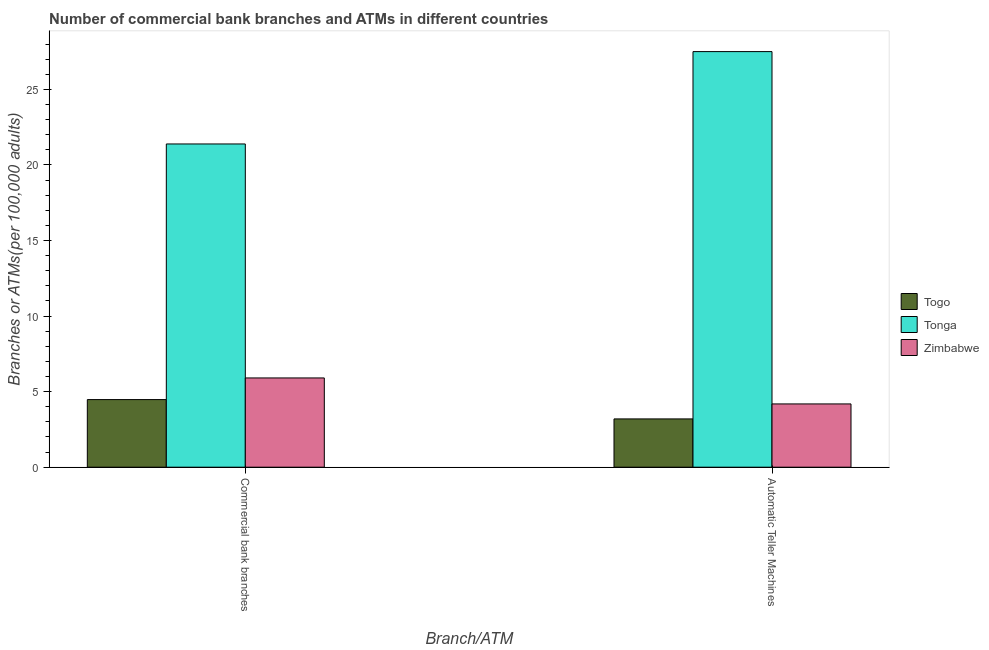What is the label of the 1st group of bars from the left?
Offer a very short reply. Commercial bank branches. What is the number of commercal bank branches in Tonga?
Your response must be concise. 21.39. Across all countries, what is the maximum number of atms?
Ensure brevity in your answer.  27.5. Across all countries, what is the minimum number of atms?
Keep it short and to the point. 3.2. In which country was the number of commercal bank branches maximum?
Offer a terse response. Tonga. In which country was the number of commercal bank branches minimum?
Your response must be concise. Togo. What is the total number of commercal bank branches in the graph?
Provide a short and direct response. 31.77. What is the difference between the number of commercal bank branches in Togo and that in Zimbabwe?
Your answer should be very brief. -1.43. What is the difference between the number of atms in Togo and the number of commercal bank branches in Tonga?
Offer a terse response. -18.19. What is the average number of commercal bank branches per country?
Ensure brevity in your answer.  10.59. What is the difference between the number of commercal bank branches and number of atms in Tonga?
Your answer should be very brief. -6.11. In how many countries, is the number of atms greater than 25 ?
Offer a very short reply. 1. What is the ratio of the number of commercal bank branches in Zimbabwe to that in Tonga?
Ensure brevity in your answer.  0.28. In how many countries, is the number of commercal bank branches greater than the average number of commercal bank branches taken over all countries?
Make the answer very short. 1. What does the 2nd bar from the left in Commercial bank branches represents?
Your answer should be compact. Tonga. What does the 3rd bar from the right in Automatic Teller Machines represents?
Offer a terse response. Togo. How many countries are there in the graph?
Offer a very short reply. 3. What is the difference between two consecutive major ticks on the Y-axis?
Keep it short and to the point. 5. Are the values on the major ticks of Y-axis written in scientific E-notation?
Keep it short and to the point. No. Does the graph contain any zero values?
Give a very brief answer. No. Where does the legend appear in the graph?
Provide a short and direct response. Center right. What is the title of the graph?
Your response must be concise. Number of commercial bank branches and ATMs in different countries. What is the label or title of the X-axis?
Ensure brevity in your answer.  Branch/ATM. What is the label or title of the Y-axis?
Keep it short and to the point. Branches or ATMs(per 100,0 adults). What is the Branches or ATMs(per 100,000 adults) of Togo in Commercial bank branches?
Make the answer very short. 4.47. What is the Branches or ATMs(per 100,000 adults) of Tonga in Commercial bank branches?
Provide a short and direct response. 21.39. What is the Branches or ATMs(per 100,000 adults) of Zimbabwe in Commercial bank branches?
Provide a succinct answer. 5.91. What is the Branches or ATMs(per 100,000 adults) in Togo in Automatic Teller Machines?
Offer a very short reply. 3.2. What is the Branches or ATMs(per 100,000 adults) in Tonga in Automatic Teller Machines?
Your answer should be very brief. 27.5. What is the Branches or ATMs(per 100,000 adults) of Zimbabwe in Automatic Teller Machines?
Give a very brief answer. 4.19. Across all Branch/ATM, what is the maximum Branches or ATMs(per 100,000 adults) in Togo?
Ensure brevity in your answer.  4.47. Across all Branch/ATM, what is the maximum Branches or ATMs(per 100,000 adults) of Tonga?
Offer a very short reply. 27.5. Across all Branch/ATM, what is the maximum Branches or ATMs(per 100,000 adults) of Zimbabwe?
Provide a short and direct response. 5.91. Across all Branch/ATM, what is the minimum Branches or ATMs(per 100,000 adults) in Togo?
Your answer should be very brief. 3.2. Across all Branch/ATM, what is the minimum Branches or ATMs(per 100,000 adults) in Tonga?
Ensure brevity in your answer.  21.39. Across all Branch/ATM, what is the minimum Branches or ATMs(per 100,000 adults) of Zimbabwe?
Keep it short and to the point. 4.19. What is the total Branches or ATMs(per 100,000 adults) in Togo in the graph?
Keep it short and to the point. 7.67. What is the total Branches or ATMs(per 100,000 adults) of Tonga in the graph?
Offer a very short reply. 48.88. What is the total Branches or ATMs(per 100,000 adults) in Zimbabwe in the graph?
Offer a very short reply. 10.09. What is the difference between the Branches or ATMs(per 100,000 adults) in Togo in Commercial bank branches and that in Automatic Teller Machines?
Give a very brief answer. 1.28. What is the difference between the Branches or ATMs(per 100,000 adults) in Tonga in Commercial bank branches and that in Automatic Teller Machines?
Provide a short and direct response. -6.11. What is the difference between the Branches or ATMs(per 100,000 adults) in Zimbabwe in Commercial bank branches and that in Automatic Teller Machines?
Your answer should be very brief. 1.72. What is the difference between the Branches or ATMs(per 100,000 adults) in Togo in Commercial bank branches and the Branches or ATMs(per 100,000 adults) in Tonga in Automatic Teller Machines?
Ensure brevity in your answer.  -23.02. What is the difference between the Branches or ATMs(per 100,000 adults) of Togo in Commercial bank branches and the Branches or ATMs(per 100,000 adults) of Zimbabwe in Automatic Teller Machines?
Your answer should be very brief. 0.29. What is the difference between the Branches or ATMs(per 100,000 adults) in Tonga in Commercial bank branches and the Branches or ATMs(per 100,000 adults) in Zimbabwe in Automatic Teller Machines?
Offer a terse response. 17.2. What is the average Branches or ATMs(per 100,000 adults) in Togo per Branch/ATM?
Your answer should be very brief. 3.83. What is the average Branches or ATMs(per 100,000 adults) in Tonga per Branch/ATM?
Your answer should be very brief. 24.44. What is the average Branches or ATMs(per 100,000 adults) in Zimbabwe per Branch/ATM?
Your response must be concise. 5.05. What is the difference between the Branches or ATMs(per 100,000 adults) in Togo and Branches or ATMs(per 100,000 adults) in Tonga in Commercial bank branches?
Provide a succinct answer. -16.91. What is the difference between the Branches or ATMs(per 100,000 adults) in Togo and Branches or ATMs(per 100,000 adults) in Zimbabwe in Commercial bank branches?
Give a very brief answer. -1.43. What is the difference between the Branches or ATMs(per 100,000 adults) of Tonga and Branches or ATMs(per 100,000 adults) of Zimbabwe in Commercial bank branches?
Give a very brief answer. 15.48. What is the difference between the Branches or ATMs(per 100,000 adults) of Togo and Branches or ATMs(per 100,000 adults) of Tonga in Automatic Teller Machines?
Your response must be concise. -24.3. What is the difference between the Branches or ATMs(per 100,000 adults) in Togo and Branches or ATMs(per 100,000 adults) in Zimbabwe in Automatic Teller Machines?
Keep it short and to the point. -0.99. What is the difference between the Branches or ATMs(per 100,000 adults) of Tonga and Branches or ATMs(per 100,000 adults) of Zimbabwe in Automatic Teller Machines?
Your answer should be very brief. 23.31. What is the ratio of the Branches or ATMs(per 100,000 adults) in Zimbabwe in Commercial bank branches to that in Automatic Teller Machines?
Offer a very short reply. 1.41. What is the difference between the highest and the second highest Branches or ATMs(per 100,000 adults) in Togo?
Ensure brevity in your answer.  1.28. What is the difference between the highest and the second highest Branches or ATMs(per 100,000 adults) in Tonga?
Provide a short and direct response. 6.11. What is the difference between the highest and the second highest Branches or ATMs(per 100,000 adults) of Zimbabwe?
Your answer should be very brief. 1.72. What is the difference between the highest and the lowest Branches or ATMs(per 100,000 adults) of Togo?
Make the answer very short. 1.28. What is the difference between the highest and the lowest Branches or ATMs(per 100,000 adults) in Tonga?
Give a very brief answer. 6.11. What is the difference between the highest and the lowest Branches or ATMs(per 100,000 adults) in Zimbabwe?
Provide a short and direct response. 1.72. 